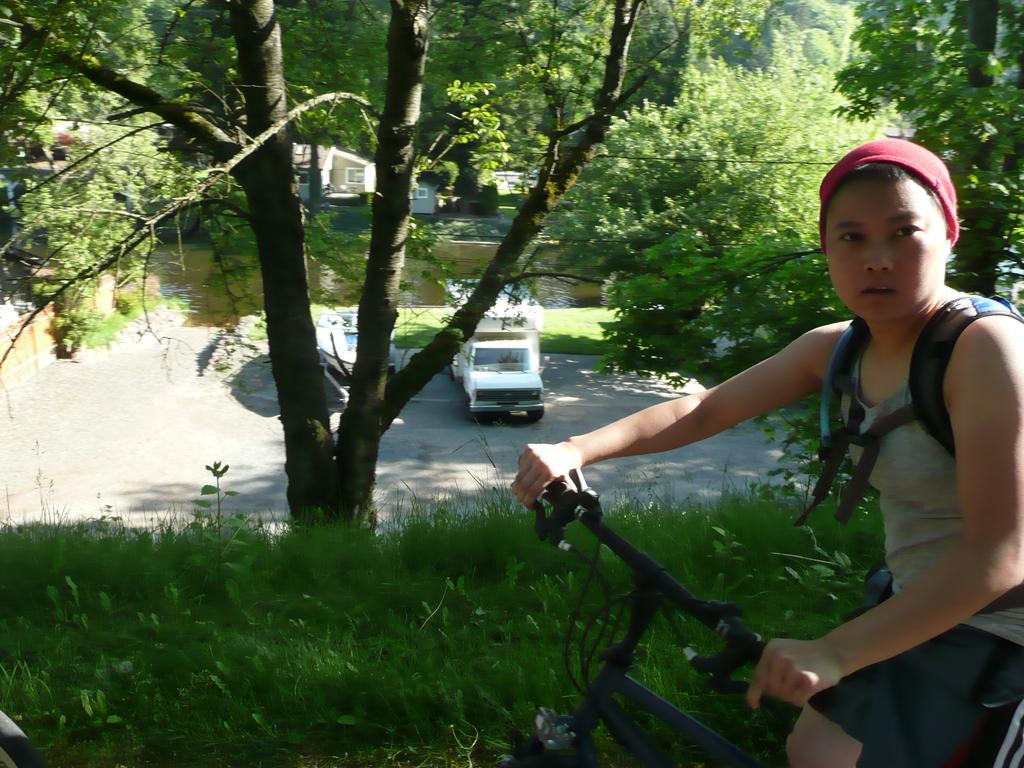What type of plant can be seen in the image? There is a tree in the image. What is on the road in the image? There is a truck on the road in the image. What type of vegetation is visible in the image? There is grass visible in the image. Who is present in the image? There is a boy in the image. What is the boy doing in the image? The boy is riding a bicycle. What type of destruction can be seen in the image? There is no destruction present in the image. What type of juice is the boy drinking in the image? There is no juice present in the image; the boy is riding a bicycle. What type of religious symbol can be seen in the image? There is no religious symbol present in the image. 